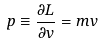<formula> <loc_0><loc_0><loc_500><loc_500>p \equiv \frac { \partial L } { \partial v } = m v</formula> 